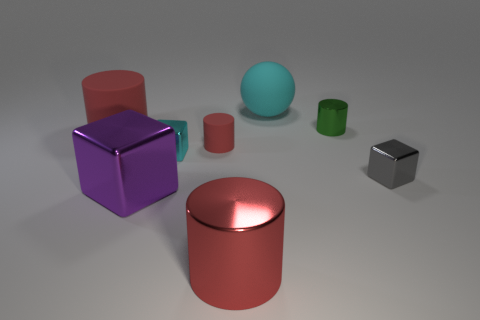How many large things are either cyan rubber objects or cyan cubes?
Keep it short and to the point. 1. Is there any other thing that has the same color as the large sphere?
Offer a terse response. Yes. Do the red rubber object to the left of the purple metal thing and the big sphere have the same size?
Ensure brevity in your answer.  Yes. There is a small cylinder on the right side of the cyan object that is behind the large matte thing that is on the left side of the big rubber sphere; what color is it?
Ensure brevity in your answer.  Green. What color is the big block?
Ensure brevity in your answer.  Purple. Does the small matte object have the same color as the large rubber cylinder?
Provide a succinct answer. Yes. Do the cyan object that is in front of the large cyan object and the small block that is on the right side of the tiny green shiny cylinder have the same material?
Ensure brevity in your answer.  Yes. What material is the other tiny thing that is the same shape as the small red rubber thing?
Your answer should be compact. Metal. Are the tiny red cylinder and the big purple cube made of the same material?
Ensure brevity in your answer.  No. There is a large thing on the right side of the big cylinder that is in front of the gray object; what is its color?
Make the answer very short. Cyan. 